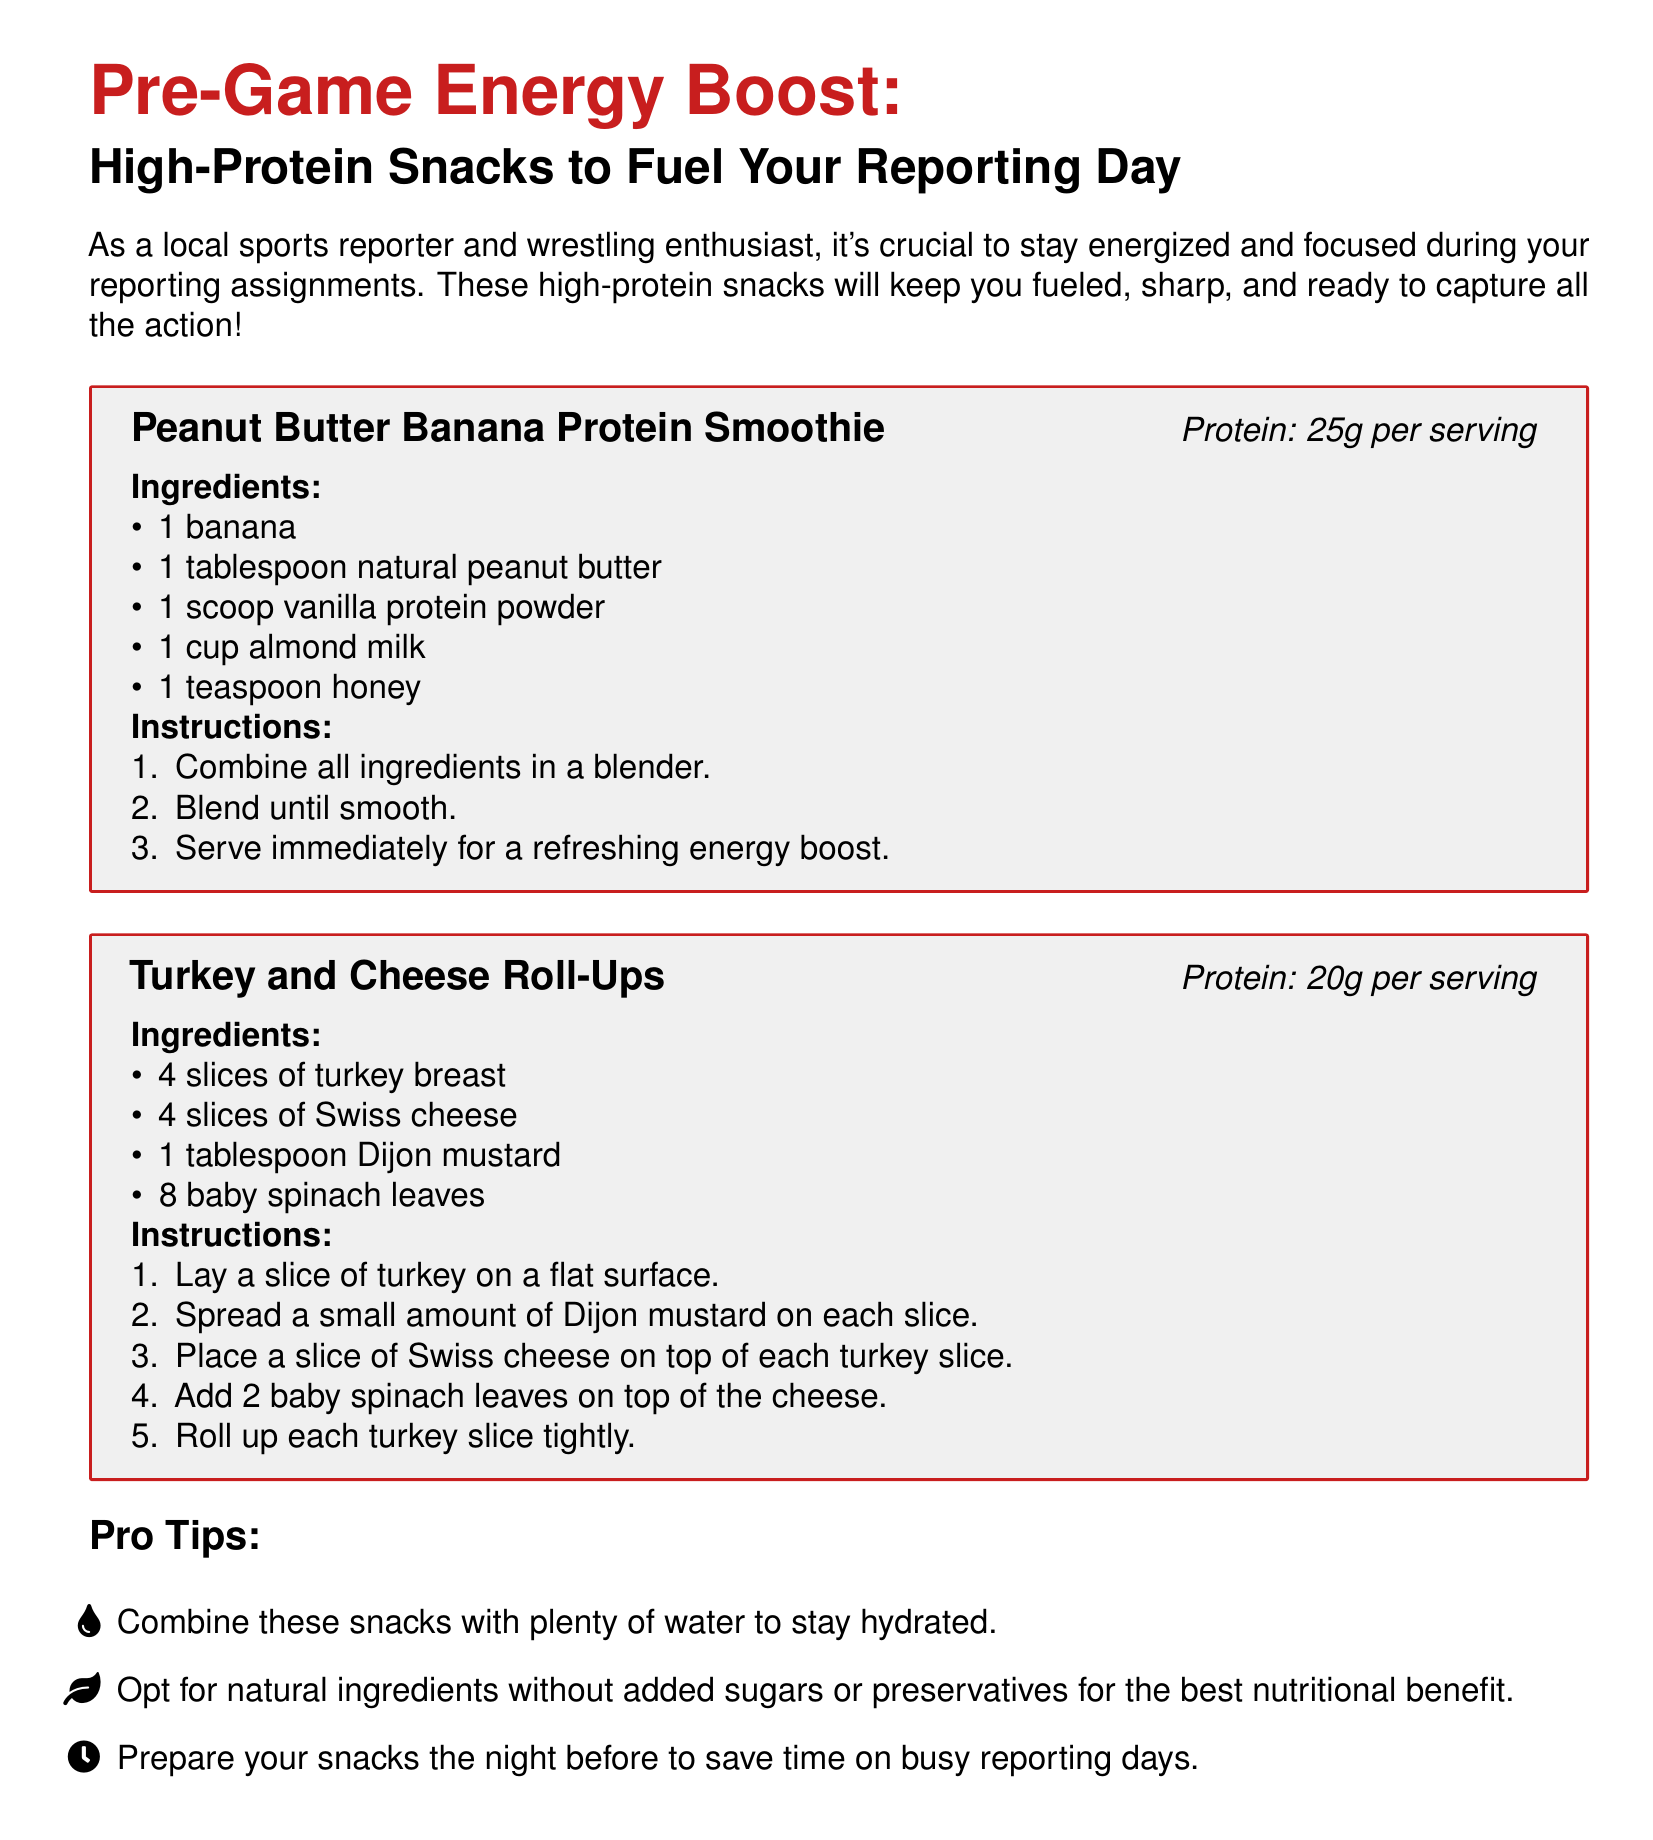What is the main purpose of the document? The document provides recipes for snacks that help local sports reporters stay energized and focused during their assignments.
Answer: High-Protein Snacks How many ingredients are in the Peanut Butter Banana Protein Smoothie? The recipe lists five ingredients you need to make the smoothie.
Answer: 5 What is the protein content of Turkey and Cheese Roll-Ups? The document states that this recipe provides 20 grams of protein per serving.
Answer: 20g per serving What ingredient is used in both recipes? Both recipes include natural peanut butter as a key ingredient.
Answer: None What is one of the pro tips provided in the document? The document offers several tips, including one that recommends staying hydrated with plenty of water.
Answer: Stay hydrated What should you do to save time on busy reporting days? The document mentions preparing snacks the night before as a time-saving strategy.
Answer: Prepare snacks the night before What is the primary protein source in the Peanut Butter Banana Protein Smoothie? The smoothie recipe includes a scoop of vanilla protein powder as the main protein source.
Answer: Vanilla protein powder How many slices of turkey breast are required for the Turkey and Cheese Roll-Ups? The recipe specifies that you need four slices of turkey breast for the roll-ups.
Answer: 4 slices 